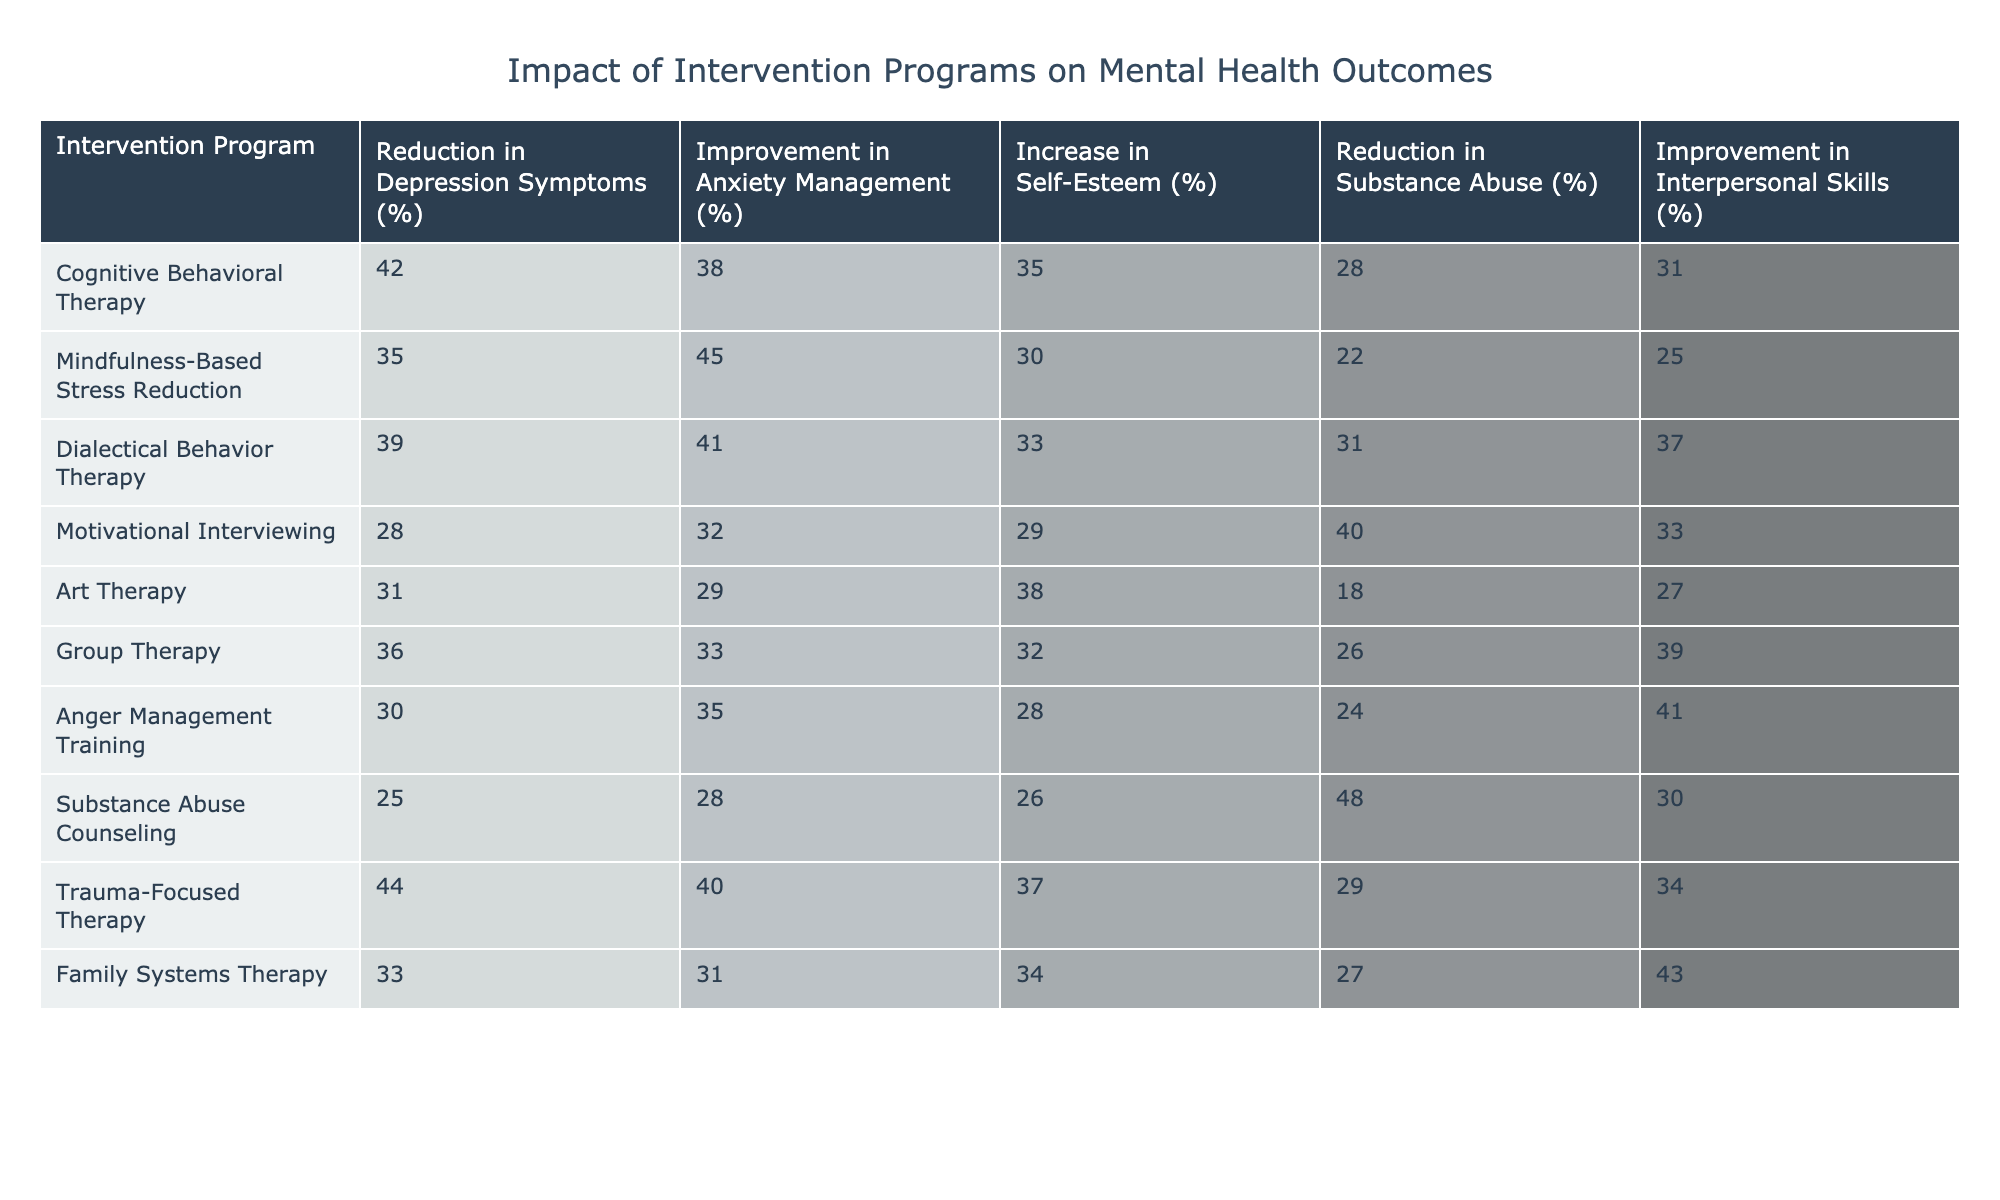What is the percentage reduction in depression symptoms for the Cognitive Behavioral Therapy program? According to the table, the percentage reduction in depression symptoms for Cognitive Behavioral Therapy is listed in the corresponding row, which shows a value of 42%.
Answer: 42% Which intervention program has the highest improvement in anxiety management? By scanning the "Improvement in Anxiety Management (%)" column, the highest percentage is found alongside Mindfulness-Based Stress Reduction, which has a value of 45%.
Answer: Mindfulness-Based Stress Reduction Calculate the average increase in self-esteem across all intervention programs. First, sum the values for the increase in self-esteem: (35 + 30 + 33 + 29 + 38 + 32 + 28 + 26 + 37 + 34) = 392. There are 10 programs, so the average is 392 / 10 = 39.2.
Answer: 39.2 Is there an intervention program that resulted in a 40% or more reduction in substance abuse? A quick check of the "Reduction in Substance Abuse (%)" column reveals that Substance Abuse Counseling has a 48% reduction, which is indeed 40% or more.
Answer: Yes Which intervention program shows the highest overall improvement across all mental health outcomes? To determine this, we sum the percentages of each program across all five outcomes. For example, the sum for Trauma-Focused Therapy is (44 + 40 + 37 + 29 + 34) = 184, and similarly calculate for others. The maximum sum is found to be 184 for Trauma-Focused Therapy.
Answer: Trauma-Focused Therapy What is the percentage improvement in interpersonal skills for Group Therapy? Referring to the "Improvement in Interpersonal Skills (%)" column, the percentage for Group Therapy is recorded as 39%.
Answer: 39% Does Art Therapy show a higher percentage reduction in depression symptoms than Anger Management Training? Comparing the values in the "Reduction in Depression Symptoms (%)" column for both programs, Art Therapy has 31% while Anger Management Training shows 30%. Thus, Art Therapy has a higher percentage.
Answer: Yes Which program has the least impact on all outcomes based on the lowest individual percentage? Examining each row, Substance Abuse Counseling consistently shows lower values across outcomes, particularly with a 25% reduction in depression symptoms, making it the least impactful program overall.
Answer: Substance Abuse Counseling 